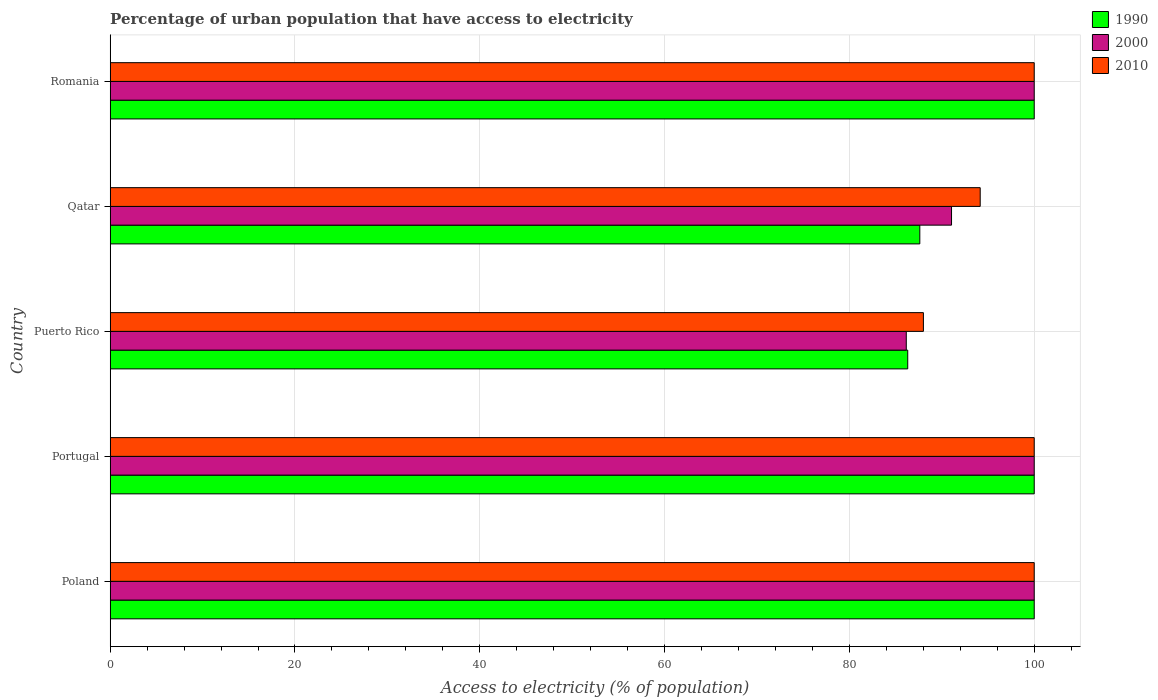How many different coloured bars are there?
Your answer should be very brief. 3. What is the label of the 1st group of bars from the top?
Offer a very short reply. Romania. Across all countries, what is the maximum percentage of urban population that have access to electricity in 1990?
Your response must be concise. 100. Across all countries, what is the minimum percentage of urban population that have access to electricity in 2000?
Offer a terse response. 86.15. In which country was the percentage of urban population that have access to electricity in 2000 minimum?
Provide a succinct answer. Puerto Rico. What is the total percentage of urban population that have access to electricity in 2000 in the graph?
Your answer should be compact. 477.21. What is the difference between the percentage of urban population that have access to electricity in 2010 in Qatar and that in Romania?
Your answer should be compact. -5.85. What is the difference between the percentage of urban population that have access to electricity in 2000 in Poland and the percentage of urban population that have access to electricity in 2010 in Qatar?
Provide a short and direct response. 5.85. What is the average percentage of urban population that have access to electricity in 2000 per country?
Provide a short and direct response. 95.44. In how many countries, is the percentage of urban population that have access to electricity in 2000 greater than 68 %?
Provide a succinct answer. 5. What is the ratio of the percentage of urban population that have access to electricity in 1990 in Portugal to that in Puerto Rico?
Offer a terse response. 1.16. Is the difference between the percentage of urban population that have access to electricity in 2000 in Poland and Portugal greater than the difference between the percentage of urban population that have access to electricity in 2010 in Poland and Portugal?
Offer a terse response. No. What is the difference between the highest and the lowest percentage of urban population that have access to electricity in 2010?
Your answer should be compact. 11.99. Is the sum of the percentage of urban population that have access to electricity in 1990 in Portugal and Romania greater than the maximum percentage of urban population that have access to electricity in 2010 across all countries?
Keep it short and to the point. Yes. What does the 3rd bar from the top in Puerto Rico represents?
Offer a very short reply. 1990. What does the 1st bar from the bottom in Portugal represents?
Your answer should be very brief. 1990. What is the difference between two consecutive major ticks on the X-axis?
Give a very brief answer. 20. Are the values on the major ticks of X-axis written in scientific E-notation?
Provide a short and direct response. No. Does the graph contain any zero values?
Make the answer very short. No. What is the title of the graph?
Provide a short and direct response. Percentage of urban population that have access to electricity. Does "1960" appear as one of the legend labels in the graph?
Offer a very short reply. No. What is the label or title of the X-axis?
Ensure brevity in your answer.  Access to electricity (% of population). What is the label or title of the Y-axis?
Your answer should be very brief. Country. What is the Access to electricity (% of population) of 1990 in Poland?
Ensure brevity in your answer.  100. What is the Access to electricity (% of population) of 2000 in Poland?
Your answer should be compact. 100. What is the Access to electricity (% of population) in 1990 in Portugal?
Give a very brief answer. 100. What is the Access to electricity (% of population) of 2000 in Portugal?
Ensure brevity in your answer.  100. What is the Access to electricity (% of population) in 2010 in Portugal?
Your answer should be very brief. 100. What is the Access to electricity (% of population) in 1990 in Puerto Rico?
Keep it short and to the point. 86.31. What is the Access to electricity (% of population) in 2000 in Puerto Rico?
Your answer should be very brief. 86.15. What is the Access to electricity (% of population) in 2010 in Puerto Rico?
Make the answer very short. 88.01. What is the Access to electricity (% of population) of 1990 in Qatar?
Keep it short and to the point. 87.62. What is the Access to electricity (% of population) of 2000 in Qatar?
Your answer should be very brief. 91.05. What is the Access to electricity (% of population) in 2010 in Qatar?
Your answer should be very brief. 94.15. What is the Access to electricity (% of population) in 1990 in Romania?
Offer a terse response. 100. What is the Access to electricity (% of population) in 2000 in Romania?
Offer a terse response. 100. What is the Access to electricity (% of population) in 2010 in Romania?
Ensure brevity in your answer.  100. Across all countries, what is the maximum Access to electricity (% of population) of 1990?
Make the answer very short. 100. Across all countries, what is the maximum Access to electricity (% of population) in 2010?
Provide a short and direct response. 100. Across all countries, what is the minimum Access to electricity (% of population) in 1990?
Offer a terse response. 86.31. Across all countries, what is the minimum Access to electricity (% of population) of 2000?
Your answer should be very brief. 86.15. Across all countries, what is the minimum Access to electricity (% of population) in 2010?
Offer a very short reply. 88.01. What is the total Access to electricity (% of population) in 1990 in the graph?
Your answer should be very brief. 473.93. What is the total Access to electricity (% of population) in 2000 in the graph?
Ensure brevity in your answer.  477.21. What is the total Access to electricity (% of population) in 2010 in the graph?
Provide a succinct answer. 482.16. What is the difference between the Access to electricity (% of population) in 1990 in Poland and that in Portugal?
Provide a short and direct response. 0. What is the difference between the Access to electricity (% of population) of 1990 in Poland and that in Puerto Rico?
Keep it short and to the point. 13.69. What is the difference between the Access to electricity (% of population) in 2000 in Poland and that in Puerto Rico?
Make the answer very short. 13.85. What is the difference between the Access to electricity (% of population) in 2010 in Poland and that in Puerto Rico?
Give a very brief answer. 11.99. What is the difference between the Access to electricity (% of population) in 1990 in Poland and that in Qatar?
Offer a terse response. 12.38. What is the difference between the Access to electricity (% of population) in 2000 in Poland and that in Qatar?
Your response must be concise. 8.95. What is the difference between the Access to electricity (% of population) in 2010 in Poland and that in Qatar?
Your response must be concise. 5.85. What is the difference between the Access to electricity (% of population) in 1990 in Poland and that in Romania?
Provide a short and direct response. 0. What is the difference between the Access to electricity (% of population) of 1990 in Portugal and that in Puerto Rico?
Your answer should be very brief. 13.69. What is the difference between the Access to electricity (% of population) of 2000 in Portugal and that in Puerto Rico?
Ensure brevity in your answer.  13.85. What is the difference between the Access to electricity (% of population) in 2010 in Portugal and that in Puerto Rico?
Offer a terse response. 11.99. What is the difference between the Access to electricity (% of population) in 1990 in Portugal and that in Qatar?
Offer a very short reply. 12.38. What is the difference between the Access to electricity (% of population) in 2000 in Portugal and that in Qatar?
Make the answer very short. 8.95. What is the difference between the Access to electricity (% of population) in 2010 in Portugal and that in Qatar?
Your answer should be compact. 5.85. What is the difference between the Access to electricity (% of population) of 1990 in Portugal and that in Romania?
Offer a terse response. 0. What is the difference between the Access to electricity (% of population) in 2000 in Portugal and that in Romania?
Ensure brevity in your answer.  0. What is the difference between the Access to electricity (% of population) in 2010 in Portugal and that in Romania?
Make the answer very short. 0. What is the difference between the Access to electricity (% of population) in 1990 in Puerto Rico and that in Qatar?
Provide a succinct answer. -1.31. What is the difference between the Access to electricity (% of population) of 2000 in Puerto Rico and that in Qatar?
Your answer should be very brief. -4.9. What is the difference between the Access to electricity (% of population) of 2010 in Puerto Rico and that in Qatar?
Offer a very short reply. -6.15. What is the difference between the Access to electricity (% of population) of 1990 in Puerto Rico and that in Romania?
Ensure brevity in your answer.  -13.69. What is the difference between the Access to electricity (% of population) of 2000 in Puerto Rico and that in Romania?
Provide a short and direct response. -13.85. What is the difference between the Access to electricity (% of population) in 2010 in Puerto Rico and that in Romania?
Your response must be concise. -11.99. What is the difference between the Access to electricity (% of population) in 1990 in Qatar and that in Romania?
Your response must be concise. -12.38. What is the difference between the Access to electricity (% of population) in 2000 in Qatar and that in Romania?
Ensure brevity in your answer.  -8.95. What is the difference between the Access to electricity (% of population) in 2010 in Qatar and that in Romania?
Ensure brevity in your answer.  -5.85. What is the difference between the Access to electricity (% of population) of 1990 in Poland and the Access to electricity (% of population) of 2000 in Portugal?
Make the answer very short. 0. What is the difference between the Access to electricity (% of population) of 1990 in Poland and the Access to electricity (% of population) of 2010 in Portugal?
Your answer should be very brief. 0. What is the difference between the Access to electricity (% of population) in 1990 in Poland and the Access to electricity (% of population) in 2000 in Puerto Rico?
Offer a very short reply. 13.85. What is the difference between the Access to electricity (% of population) in 1990 in Poland and the Access to electricity (% of population) in 2010 in Puerto Rico?
Offer a terse response. 11.99. What is the difference between the Access to electricity (% of population) of 2000 in Poland and the Access to electricity (% of population) of 2010 in Puerto Rico?
Offer a terse response. 11.99. What is the difference between the Access to electricity (% of population) of 1990 in Poland and the Access to electricity (% of population) of 2000 in Qatar?
Make the answer very short. 8.95. What is the difference between the Access to electricity (% of population) of 1990 in Poland and the Access to electricity (% of population) of 2010 in Qatar?
Your answer should be compact. 5.85. What is the difference between the Access to electricity (% of population) of 2000 in Poland and the Access to electricity (% of population) of 2010 in Qatar?
Your response must be concise. 5.85. What is the difference between the Access to electricity (% of population) in 1990 in Poland and the Access to electricity (% of population) in 2010 in Romania?
Offer a terse response. 0. What is the difference between the Access to electricity (% of population) in 1990 in Portugal and the Access to electricity (% of population) in 2000 in Puerto Rico?
Your answer should be compact. 13.85. What is the difference between the Access to electricity (% of population) in 1990 in Portugal and the Access to electricity (% of population) in 2010 in Puerto Rico?
Your answer should be very brief. 11.99. What is the difference between the Access to electricity (% of population) in 2000 in Portugal and the Access to electricity (% of population) in 2010 in Puerto Rico?
Give a very brief answer. 11.99. What is the difference between the Access to electricity (% of population) in 1990 in Portugal and the Access to electricity (% of population) in 2000 in Qatar?
Keep it short and to the point. 8.95. What is the difference between the Access to electricity (% of population) in 1990 in Portugal and the Access to electricity (% of population) in 2010 in Qatar?
Give a very brief answer. 5.85. What is the difference between the Access to electricity (% of population) of 2000 in Portugal and the Access to electricity (% of population) of 2010 in Qatar?
Provide a succinct answer. 5.85. What is the difference between the Access to electricity (% of population) in 1990 in Portugal and the Access to electricity (% of population) in 2010 in Romania?
Provide a succinct answer. 0. What is the difference between the Access to electricity (% of population) in 1990 in Puerto Rico and the Access to electricity (% of population) in 2000 in Qatar?
Your response must be concise. -4.74. What is the difference between the Access to electricity (% of population) in 1990 in Puerto Rico and the Access to electricity (% of population) in 2010 in Qatar?
Your response must be concise. -7.84. What is the difference between the Access to electricity (% of population) of 2000 in Puerto Rico and the Access to electricity (% of population) of 2010 in Qatar?
Your answer should be very brief. -8. What is the difference between the Access to electricity (% of population) of 1990 in Puerto Rico and the Access to electricity (% of population) of 2000 in Romania?
Ensure brevity in your answer.  -13.69. What is the difference between the Access to electricity (% of population) in 1990 in Puerto Rico and the Access to electricity (% of population) in 2010 in Romania?
Provide a short and direct response. -13.69. What is the difference between the Access to electricity (% of population) of 2000 in Puerto Rico and the Access to electricity (% of population) of 2010 in Romania?
Offer a terse response. -13.85. What is the difference between the Access to electricity (% of population) of 1990 in Qatar and the Access to electricity (% of population) of 2000 in Romania?
Make the answer very short. -12.38. What is the difference between the Access to electricity (% of population) in 1990 in Qatar and the Access to electricity (% of population) in 2010 in Romania?
Provide a succinct answer. -12.38. What is the difference between the Access to electricity (% of population) in 2000 in Qatar and the Access to electricity (% of population) in 2010 in Romania?
Provide a succinct answer. -8.95. What is the average Access to electricity (% of population) of 1990 per country?
Keep it short and to the point. 94.79. What is the average Access to electricity (% of population) of 2000 per country?
Offer a terse response. 95.44. What is the average Access to electricity (% of population) of 2010 per country?
Provide a succinct answer. 96.43. What is the difference between the Access to electricity (% of population) in 1990 and Access to electricity (% of population) in 2000 in Poland?
Make the answer very short. 0. What is the difference between the Access to electricity (% of population) of 1990 and Access to electricity (% of population) of 2000 in Portugal?
Keep it short and to the point. 0. What is the difference between the Access to electricity (% of population) in 1990 and Access to electricity (% of population) in 2010 in Portugal?
Your answer should be compact. 0. What is the difference between the Access to electricity (% of population) of 2000 and Access to electricity (% of population) of 2010 in Portugal?
Give a very brief answer. 0. What is the difference between the Access to electricity (% of population) in 1990 and Access to electricity (% of population) in 2000 in Puerto Rico?
Your response must be concise. 0.16. What is the difference between the Access to electricity (% of population) in 1990 and Access to electricity (% of population) in 2010 in Puerto Rico?
Ensure brevity in your answer.  -1.7. What is the difference between the Access to electricity (% of population) of 2000 and Access to electricity (% of population) of 2010 in Puerto Rico?
Ensure brevity in your answer.  -1.85. What is the difference between the Access to electricity (% of population) in 1990 and Access to electricity (% of population) in 2000 in Qatar?
Your answer should be very brief. -3.43. What is the difference between the Access to electricity (% of population) of 1990 and Access to electricity (% of population) of 2010 in Qatar?
Your answer should be very brief. -6.54. What is the difference between the Access to electricity (% of population) in 2000 and Access to electricity (% of population) in 2010 in Qatar?
Offer a very short reply. -3.1. What is the difference between the Access to electricity (% of population) in 1990 and Access to electricity (% of population) in 2000 in Romania?
Provide a succinct answer. 0. What is the difference between the Access to electricity (% of population) of 2000 and Access to electricity (% of population) of 2010 in Romania?
Offer a very short reply. 0. What is the ratio of the Access to electricity (% of population) of 2000 in Poland to that in Portugal?
Give a very brief answer. 1. What is the ratio of the Access to electricity (% of population) of 1990 in Poland to that in Puerto Rico?
Your answer should be compact. 1.16. What is the ratio of the Access to electricity (% of population) in 2000 in Poland to that in Puerto Rico?
Your response must be concise. 1.16. What is the ratio of the Access to electricity (% of population) in 2010 in Poland to that in Puerto Rico?
Make the answer very short. 1.14. What is the ratio of the Access to electricity (% of population) in 1990 in Poland to that in Qatar?
Ensure brevity in your answer.  1.14. What is the ratio of the Access to electricity (% of population) in 2000 in Poland to that in Qatar?
Offer a terse response. 1.1. What is the ratio of the Access to electricity (% of population) of 2010 in Poland to that in Qatar?
Keep it short and to the point. 1.06. What is the ratio of the Access to electricity (% of population) of 2000 in Poland to that in Romania?
Provide a succinct answer. 1. What is the ratio of the Access to electricity (% of population) of 2010 in Poland to that in Romania?
Your response must be concise. 1. What is the ratio of the Access to electricity (% of population) of 1990 in Portugal to that in Puerto Rico?
Provide a short and direct response. 1.16. What is the ratio of the Access to electricity (% of population) in 2000 in Portugal to that in Puerto Rico?
Your answer should be compact. 1.16. What is the ratio of the Access to electricity (% of population) in 2010 in Portugal to that in Puerto Rico?
Your response must be concise. 1.14. What is the ratio of the Access to electricity (% of population) in 1990 in Portugal to that in Qatar?
Your answer should be very brief. 1.14. What is the ratio of the Access to electricity (% of population) of 2000 in Portugal to that in Qatar?
Provide a short and direct response. 1.1. What is the ratio of the Access to electricity (% of population) in 2010 in Portugal to that in Qatar?
Your answer should be very brief. 1.06. What is the ratio of the Access to electricity (% of population) in 2000 in Portugal to that in Romania?
Make the answer very short. 1. What is the ratio of the Access to electricity (% of population) in 2010 in Portugal to that in Romania?
Offer a terse response. 1. What is the ratio of the Access to electricity (% of population) of 1990 in Puerto Rico to that in Qatar?
Give a very brief answer. 0.99. What is the ratio of the Access to electricity (% of population) in 2000 in Puerto Rico to that in Qatar?
Offer a very short reply. 0.95. What is the ratio of the Access to electricity (% of population) in 2010 in Puerto Rico to that in Qatar?
Offer a terse response. 0.93. What is the ratio of the Access to electricity (% of population) of 1990 in Puerto Rico to that in Romania?
Ensure brevity in your answer.  0.86. What is the ratio of the Access to electricity (% of population) of 2000 in Puerto Rico to that in Romania?
Offer a very short reply. 0.86. What is the ratio of the Access to electricity (% of population) in 2010 in Puerto Rico to that in Romania?
Offer a terse response. 0.88. What is the ratio of the Access to electricity (% of population) in 1990 in Qatar to that in Romania?
Your answer should be very brief. 0.88. What is the ratio of the Access to electricity (% of population) in 2000 in Qatar to that in Romania?
Your answer should be compact. 0.91. What is the ratio of the Access to electricity (% of population) in 2010 in Qatar to that in Romania?
Your response must be concise. 0.94. What is the difference between the highest and the lowest Access to electricity (% of population) in 1990?
Keep it short and to the point. 13.69. What is the difference between the highest and the lowest Access to electricity (% of population) in 2000?
Ensure brevity in your answer.  13.85. What is the difference between the highest and the lowest Access to electricity (% of population) of 2010?
Provide a short and direct response. 11.99. 